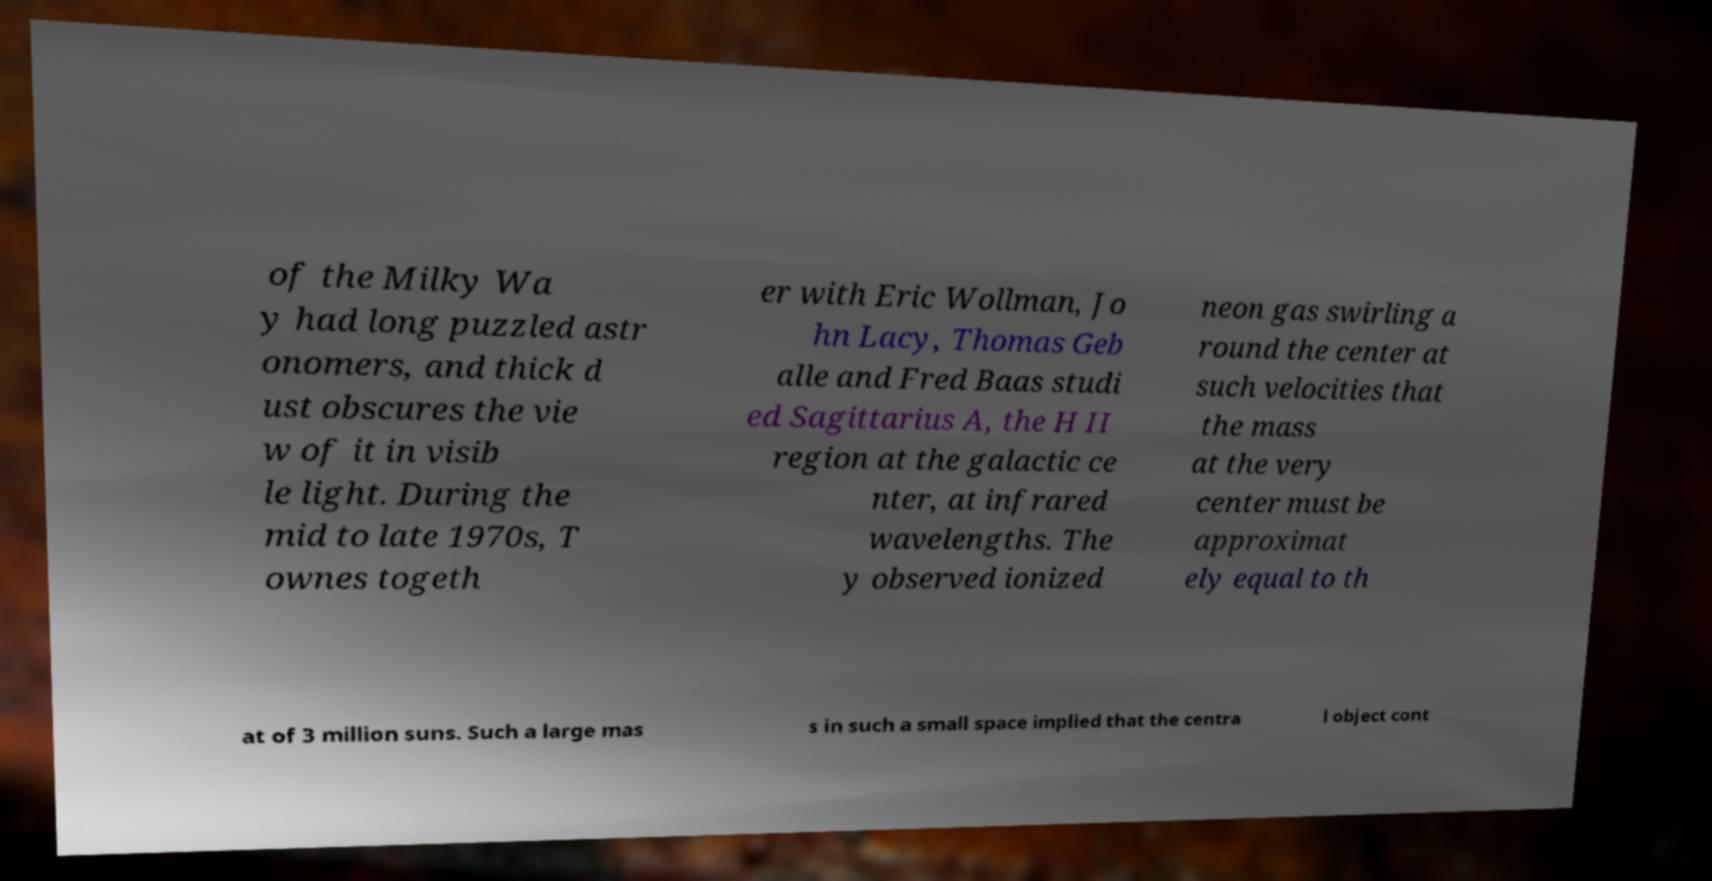There's text embedded in this image that I need extracted. Can you transcribe it verbatim? of the Milky Wa y had long puzzled astr onomers, and thick d ust obscures the vie w of it in visib le light. During the mid to late 1970s, T ownes togeth er with Eric Wollman, Jo hn Lacy, Thomas Geb alle and Fred Baas studi ed Sagittarius A, the H II region at the galactic ce nter, at infrared wavelengths. The y observed ionized neon gas swirling a round the center at such velocities that the mass at the very center must be approximat ely equal to th at of 3 million suns. Such a large mas s in such a small space implied that the centra l object cont 